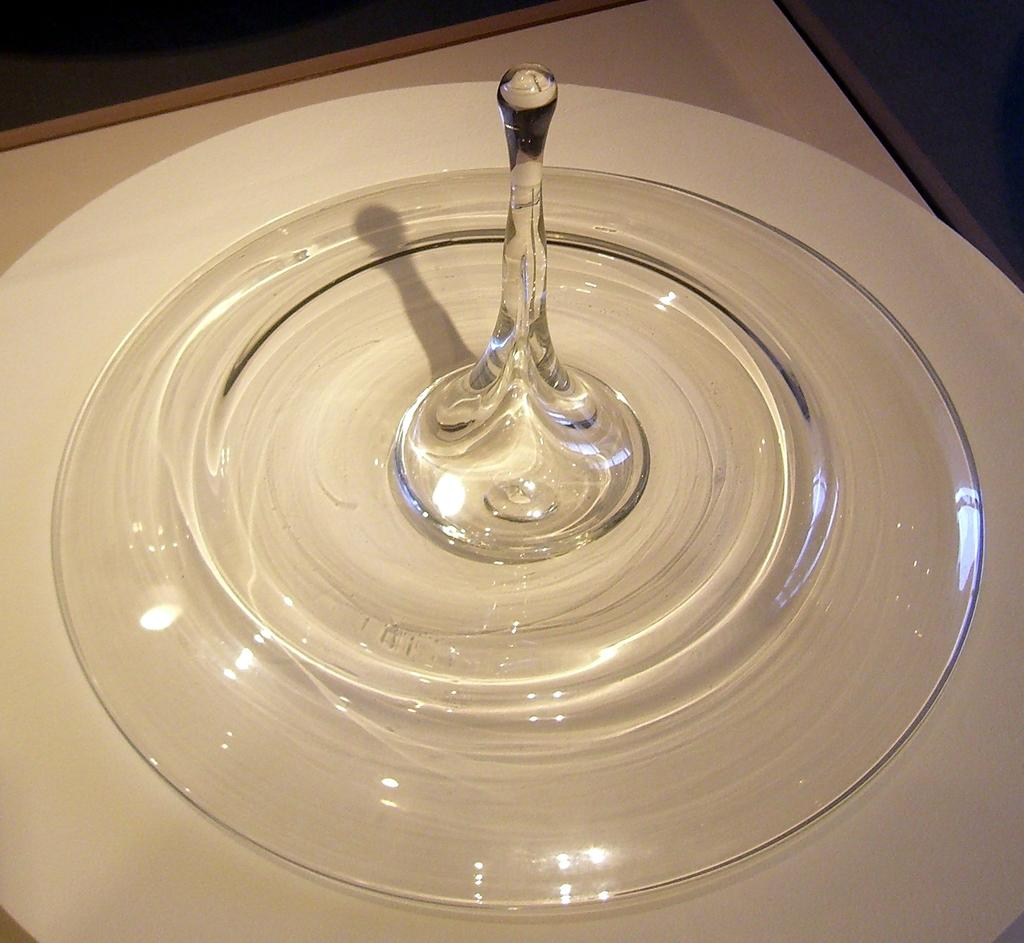What object is present on the table in the image? There is a glass plate on the table in the image. What is placed on the glass plate? There is a champagne glass on the glass plate. What is the name of the person who invented the cable used to create the acoustics in the image? There is no mention of cables or acoustics in the image, and therefore no person's name can be associated with them. 